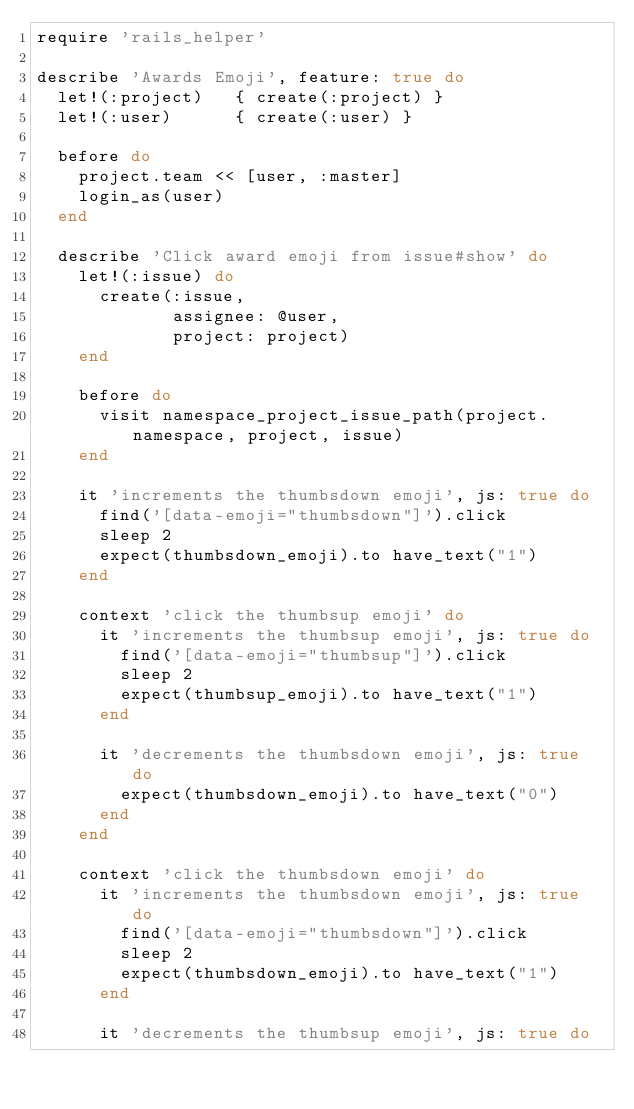Convert code to text. <code><loc_0><loc_0><loc_500><loc_500><_Ruby_>require 'rails_helper'

describe 'Awards Emoji', feature: true do
  let!(:project)   { create(:project) }
  let!(:user)      { create(:user) }

  before do
    project.team << [user, :master]
    login_as(user)
  end

  describe 'Click award emoji from issue#show' do
    let!(:issue) do
      create(:issue,
             assignee: @user,
             project: project)
    end

    before do
      visit namespace_project_issue_path(project.namespace, project, issue)
    end

    it 'increments the thumbsdown emoji', js: true do
      find('[data-emoji="thumbsdown"]').click
      sleep 2
      expect(thumbsdown_emoji).to have_text("1")
    end

    context 'click the thumbsup emoji' do
      it 'increments the thumbsup emoji', js: true do
        find('[data-emoji="thumbsup"]').click
        sleep 2
        expect(thumbsup_emoji).to have_text("1")
      end

      it 'decrements the thumbsdown emoji', js: true do
        expect(thumbsdown_emoji).to have_text("0")
      end
    end

    context 'click the thumbsdown emoji' do
      it 'increments the thumbsdown emoji', js: true do
        find('[data-emoji="thumbsdown"]').click
        sleep 2
        expect(thumbsdown_emoji).to have_text("1")
      end

      it 'decrements the thumbsup emoji', js: true do</code> 